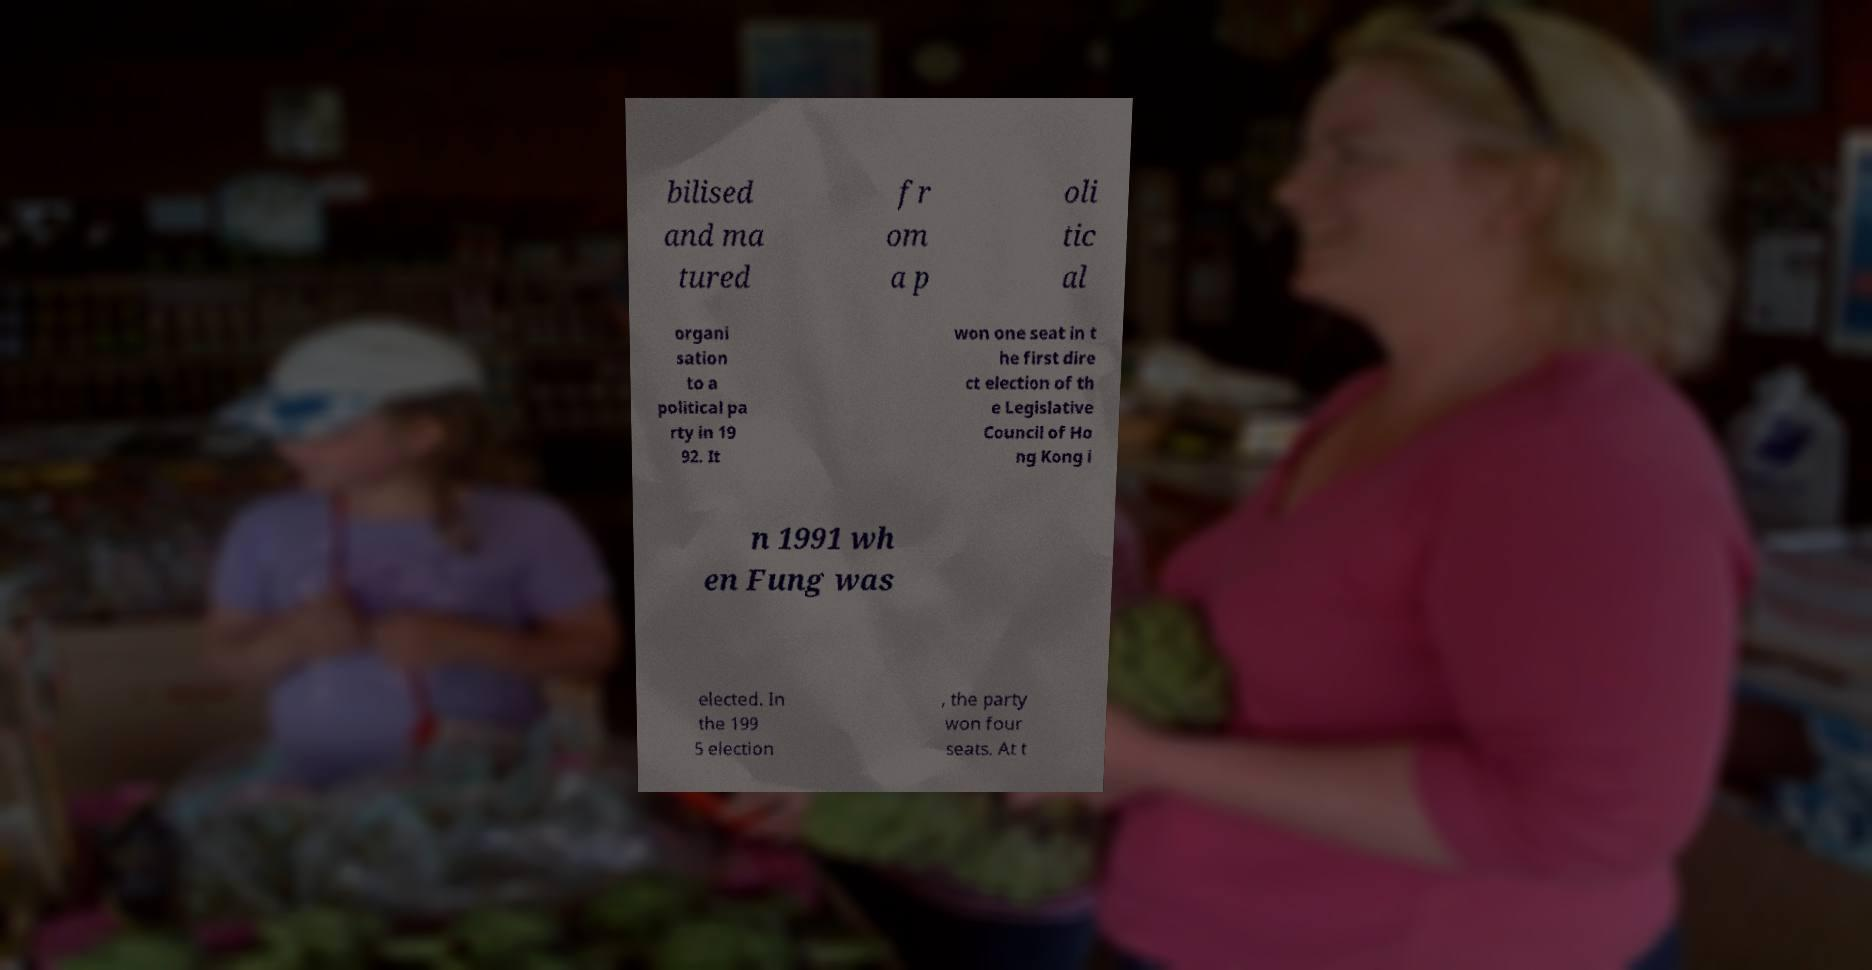For documentation purposes, I need the text within this image transcribed. Could you provide that? bilised and ma tured fr om a p oli tic al organi sation to a political pa rty in 19 92. It won one seat in t he first dire ct election of th e Legislative Council of Ho ng Kong i n 1991 wh en Fung was elected. In the 199 5 election , the party won four seats. At t 